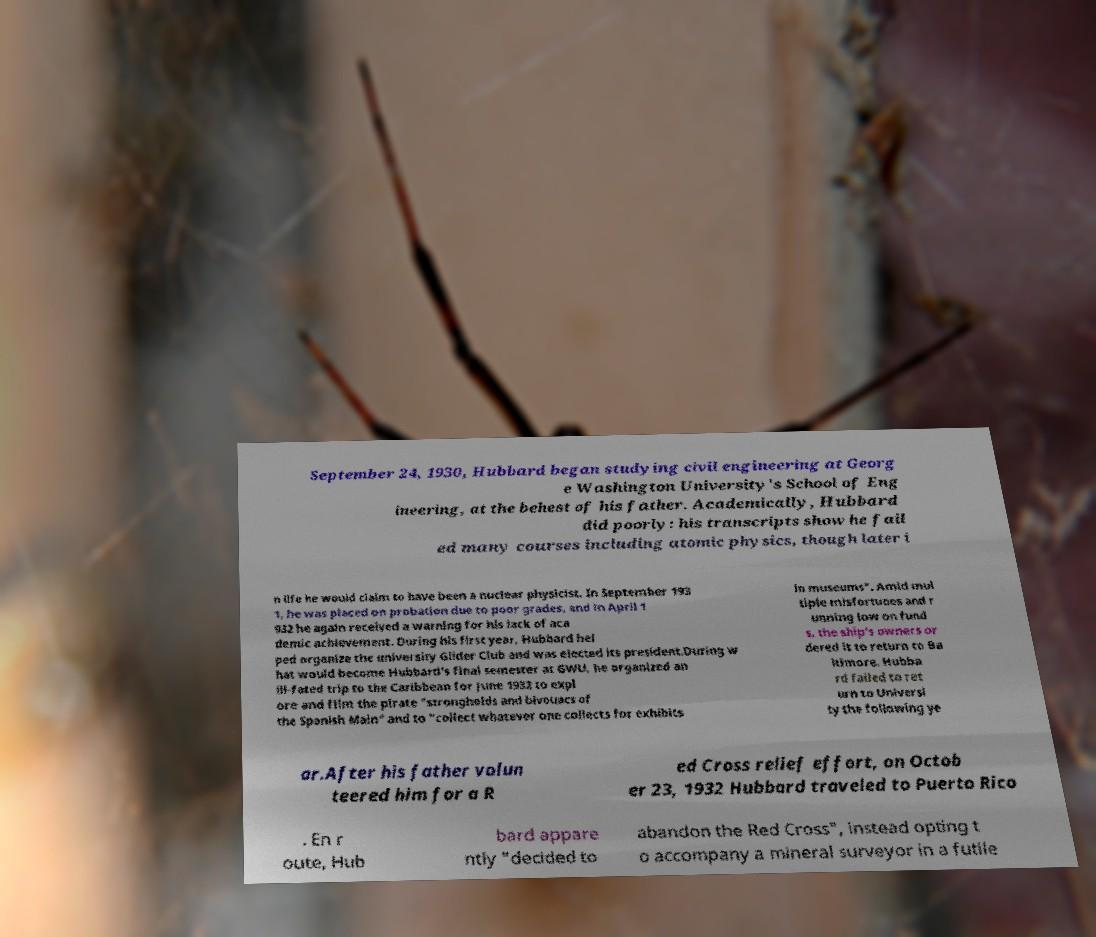What messages or text are displayed in this image? I need them in a readable, typed format. September 24, 1930, Hubbard began studying civil engineering at Georg e Washington University's School of Eng ineering, at the behest of his father. Academically, Hubbard did poorly: his transcripts show he fail ed many courses including atomic physics, though later i n life he would claim to have been a nuclear physicist. In September 193 1, he was placed on probation due to poor grades, and in April 1 932 he again received a warning for his lack of aca demic achievement. During his first year, Hubbard hel ped organize the university Glider Club and was elected its president.During w hat would become Hubbard's final semester at GWU, he organized an ill-fated trip to the Caribbean for June 1932 to expl ore and film the pirate "strongholds and bivouacs of the Spanish Main" and to "collect whatever one collects for exhibits in museums". Amid mul tiple misfortunes and r unning low on fund s, the ship's owners or dered it to return to Ba ltimore. Hubba rd failed to ret urn to Universi ty the following ye ar.After his father volun teered him for a R ed Cross relief effort, on Octob er 23, 1932 Hubbard traveled to Puerto Rico . En r oute, Hub bard appare ntly "decided to abandon the Red Cross", instead opting t o accompany a mineral surveyor in a futile 